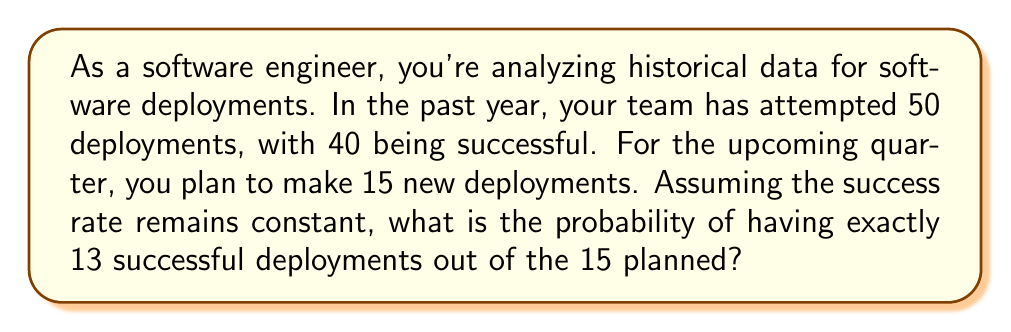What is the answer to this math problem? To solve this problem, we'll use the binomial probability formula, as we're dealing with a fixed number of independent trials (deployments) with two possible outcomes (success or failure).

Step 1: Identify the parameters
- $n$ = number of trials = 15
- $k$ = number of successes = 13
- $p$ = probability of success = 40/50 = 0.8
- $q$ = probability of failure = 1 - p = 0.2

Step 2: Use the binomial probability formula
$$P(X=k) = \binom{n}{k} p^k q^{n-k}$$

Step 3: Calculate the binomial coefficient
$$\binom{15}{13} = \frac{15!}{13!(15-13)!} = \frac{15!}{13!2!} = 105$$

Step 4: Plug values into the formula
$$P(X=13) = 105 \cdot (0.8)^{13} \cdot (0.2)^{15-13}$$
$$= 105 \cdot (0.8)^{13} \cdot (0.2)^2$$

Step 5: Calculate the result
$$= 105 \cdot 0.1281 \cdot 0.04 = 0.5380$$

Therefore, the probability of having exactly 13 successful deployments out of 15 is approximately 0.5380 or 53.80%.
Answer: 0.5380 